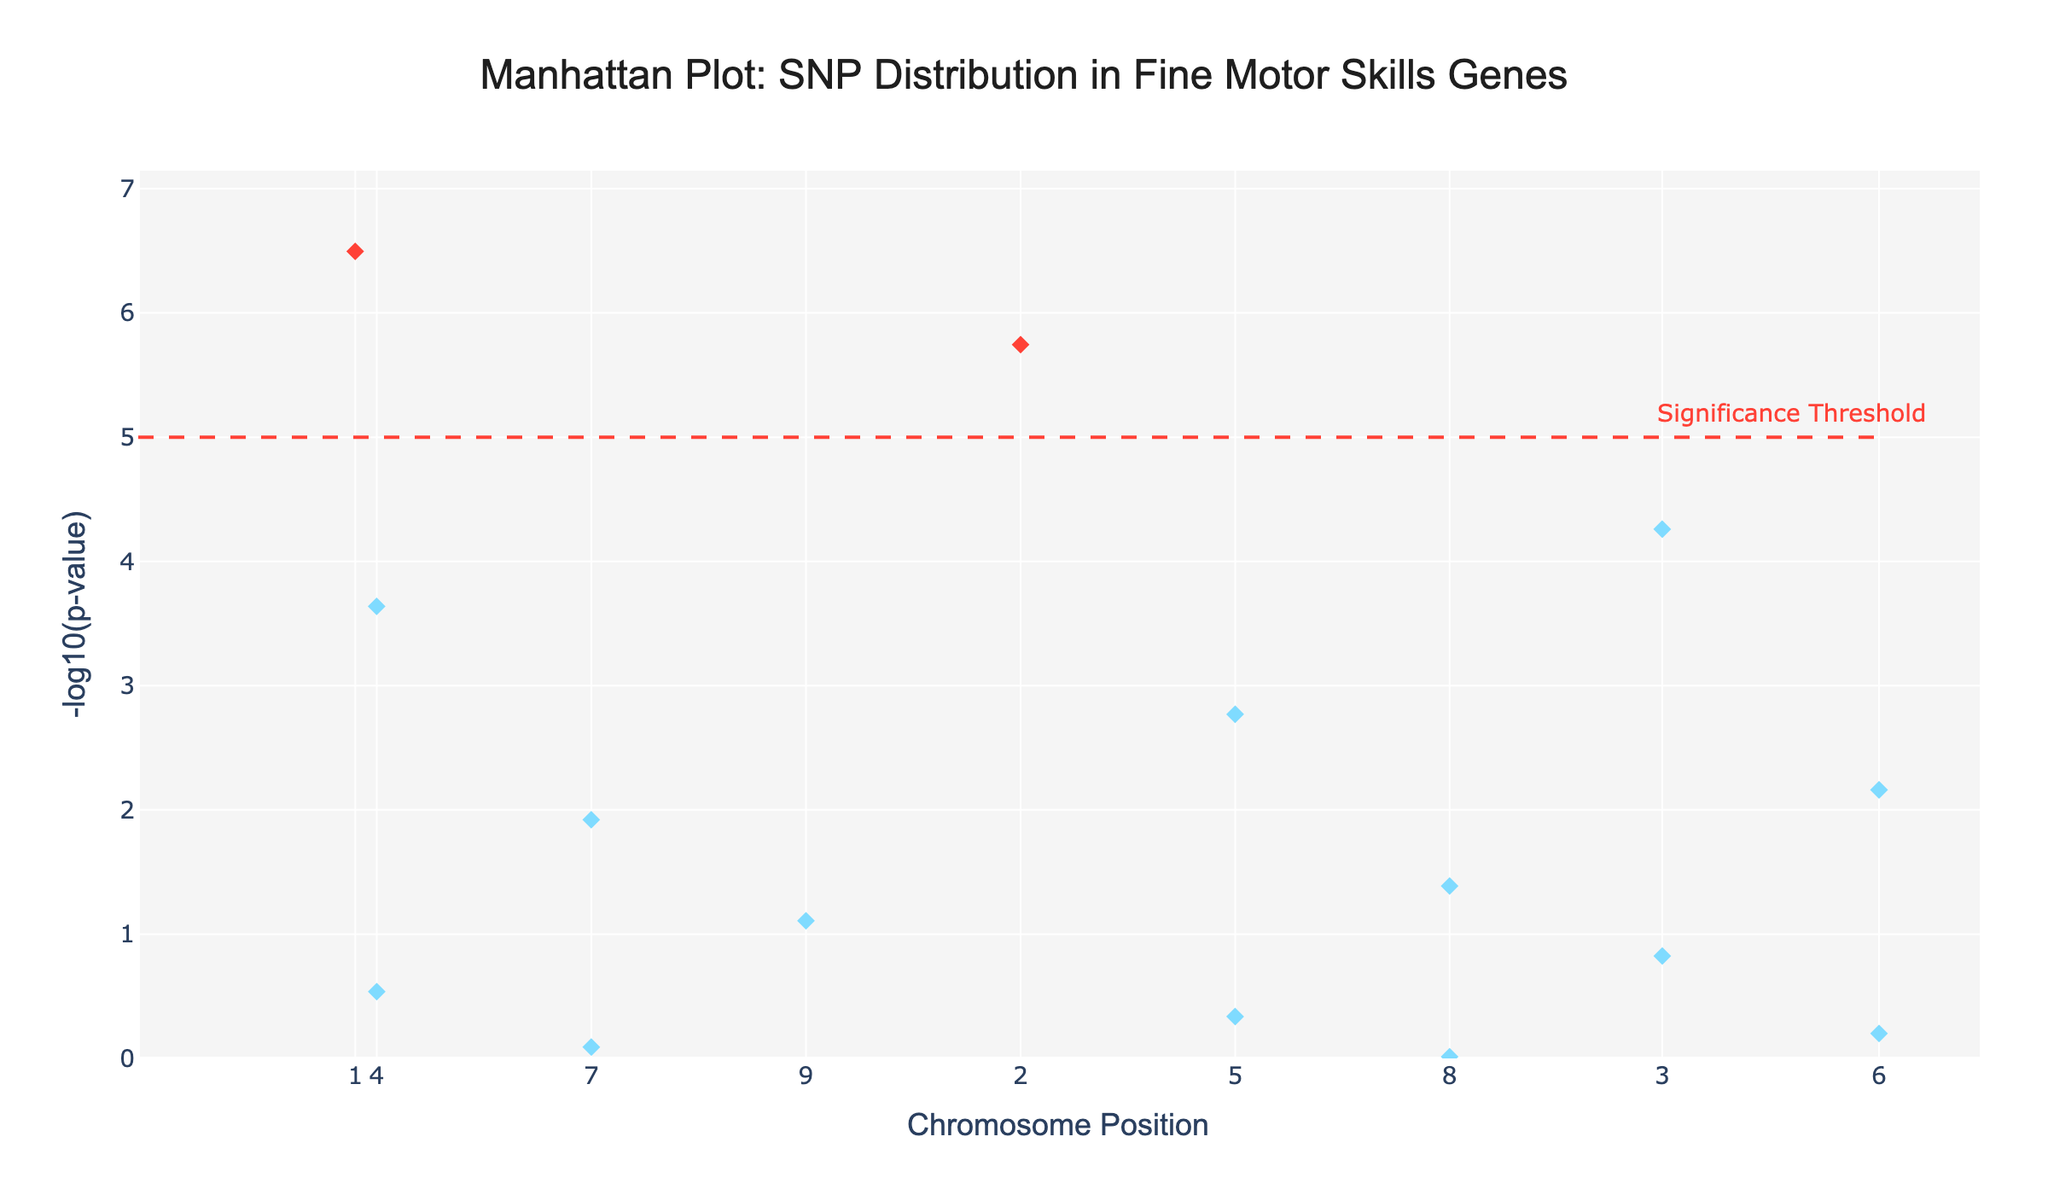What is the title of the Manhattan Plot? The title is usually placed at the top of the plot and is clearly visible in a larger font size. In this case, we look at the given plot description for the title.
Answer: Manhattan Plot: SNP Distribution in Fine Motor Skills Genes What is the range of the y-axis in the plot? The y-axis represents the -log10(p-value) in a Manhattan Plot. By inspecting the axis labels and range annotations, one can determine the span of values displayed.
Answer: 0 to approximately 7 Which chromosome has a point with the highest -log10(p-value)? One can determine the chromosome by checking the highest point on the y-axis and identifying the corresponding chromosome by the color or label provided in hover information.
Answer: Chromosome 1 How many SNPs are above the significance threshold in the plot? The significance threshold line is drawn at -log10(p) = 5. By counting the points above this line, we can determine the number of significant SNPs.
Answer: 2 Which SNP is associated with the FOXP2 gene, and what is its p-value? By using hover information over the plotted points and identifying the SNP associated with the FOXP2 gene, one can locate the SNP along with its p-value.
Answer: rs2275929, 3.2e-7 Compare the -log10(p-values) of SNPs rs6732638 and rs1801133. Which one is higher? Locate the two SNPs using hover information or by chromosome and position. Compare the respective -log10(p-values) using the y-axis.
Answer: rs6732638 is higher Which gene associated with Chromosome 5 has the lowest -log10(p-value)? By inspecting Chromosome 5 on the plot and comparing the y-axis values of points, we can identify the lowest -log10(p-value).
Answer: BDNF What is the average -log10(p-value) of SNPs on Chromosomes 4 and 7? Calculate -log10(p) for both Chromosomes 4 and 7, sum them up, and divide by the number of SNPs in these chromosomes.
Answer: (-log10(2.3e-4) + -log10(1.2e-2)) / 2 = (3.64 + 1.92) / 2 = 2.78 Which SNP out of rs2254298, rs4570625, and rs6313 has the p-value closest to 0.5? Inspect the individual SNPs using hover information or noting their positions and comparing their p-values to 0.5.
Answer: rs2254298 What is the overall distribution pattern of SNP p-values across all chromosomes? By analyzing the spread of points across the chromosomes and their respective -log10(p-values), a pattern can be deduced, whether they are spread out, cluster in specific chromosomes, etc.
Answer: The SNPs show a varied distribution with significant p-values on Chromosomes 1 and 2 